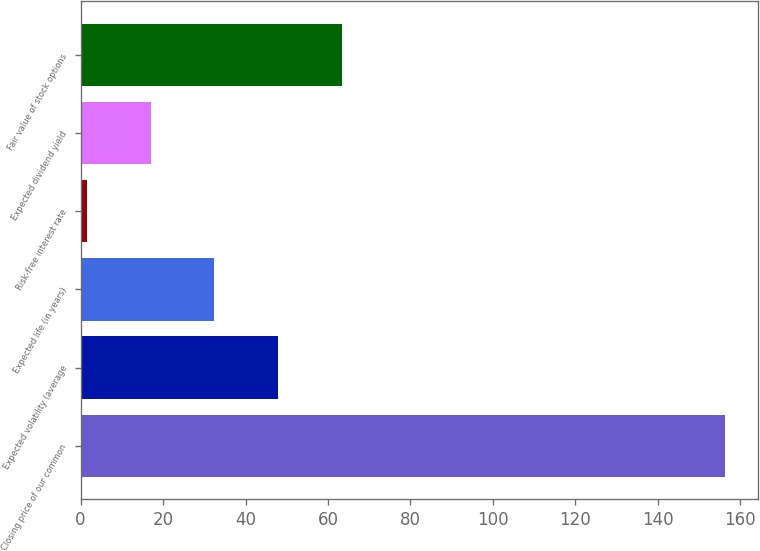Convert chart to OTSL. <chart><loc_0><loc_0><loc_500><loc_500><bar_chart><fcel>Closing price of our common<fcel>Expected volatility (average<fcel>Expected life (in years)<fcel>Risk-free interest rate<fcel>Expected dividend yield<fcel>Fair value of stock options<nl><fcel>156.35<fcel>47.95<fcel>32.47<fcel>1.5<fcel>16.98<fcel>63.44<nl></chart> 